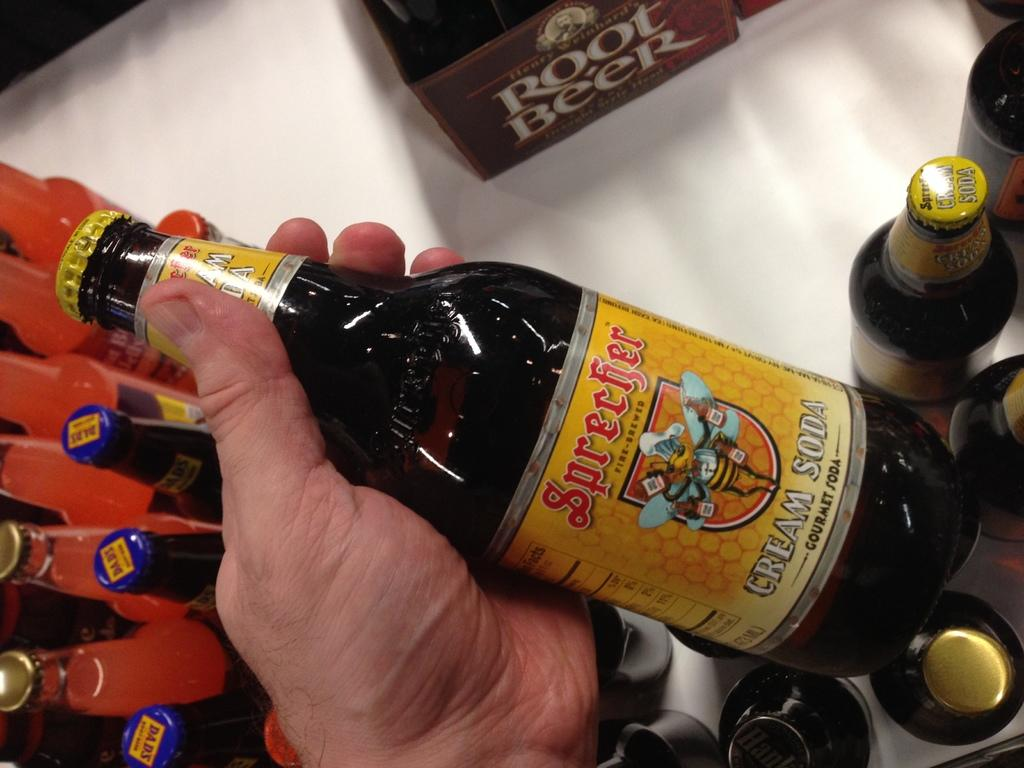Who is present in the image? There is a person in the image. What is the person holding in the image? The person is holding a bottle. Are there any other bottles visible in the image? Yes, there are bottles visible in the image. What type of mice can be seen running around the bottles in the image? There are no mice present in the image; it only features a person holding a bottle and other visible bottles. 